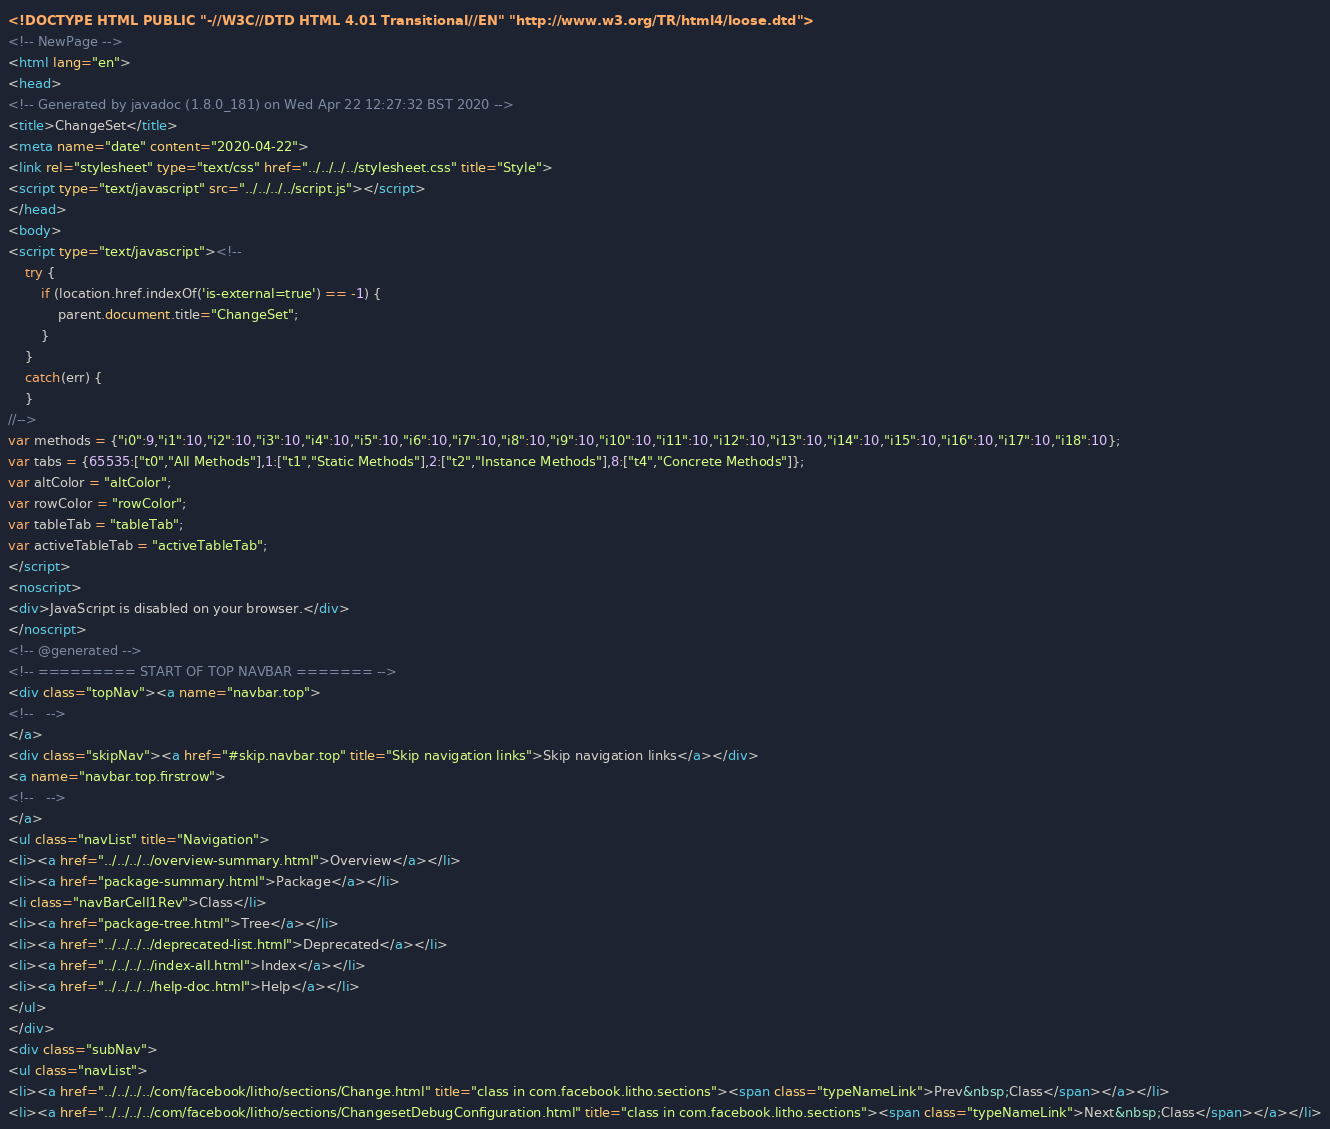Convert code to text. <code><loc_0><loc_0><loc_500><loc_500><_HTML_><!DOCTYPE HTML PUBLIC "-//W3C//DTD HTML 4.01 Transitional//EN" "http://www.w3.org/TR/html4/loose.dtd">
<!-- NewPage -->
<html lang="en">
<head>
<!-- Generated by javadoc (1.8.0_181) on Wed Apr 22 12:27:32 BST 2020 -->
<title>ChangeSet</title>
<meta name="date" content="2020-04-22">
<link rel="stylesheet" type="text/css" href="../../../../stylesheet.css" title="Style">
<script type="text/javascript" src="../../../../script.js"></script>
</head>
<body>
<script type="text/javascript"><!--
    try {
        if (location.href.indexOf('is-external=true') == -1) {
            parent.document.title="ChangeSet";
        }
    }
    catch(err) {
    }
//-->
var methods = {"i0":9,"i1":10,"i2":10,"i3":10,"i4":10,"i5":10,"i6":10,"i7":10,"i8":10,"i9":10,"i10":10,"i11":10,"i12":10,"i13":10,"i14":10,"i15":10,"i16":10,"i17":10,"i18":10};
var tabs = {65535:["t0","All Methods"],1:["t1","Static Methods"],2:["t2","Instance Methods"],8:["t4","Concrete Methods"]};
var altColor = "altColor";
var rowColor = "rowColor";
var tableTab = "tableTab";
var activeTableTab = "activeTableTab";
</script>
<noscript>
<div>JavaScript is disabled on your browser.</div>
</noscript>
<!-- @generated -->
<!-- ========= START OF TOP NAVBAR ======= -->
<div class="topNav"><a name="navbar.top">
<!--   -->
</a>
<div class="skipNav"><a href="#skip.navbar.top" title="Skip navigation links">Skip navigation links</a></div>
<a name="navbar.top.firstrow">
<!--   -->
</a>
<ul class="navList" title="Navigation">
<li><a href="../../../../overview-summary.html">Overview</a></li>
<li><a href="package-summary.html">Package</a></li>
<li class="navBarCell1Rev">Class</li>
<li><a href="package-tree.html">Tree</a></li>
<li><a href="../../../../deprecated-list.html">Deprecated</a></li>
<li><a href="../../../../index-all.html">Index</a></li>
<li><a href="../../../../help-doc.html">Help</a></li>
</ul>
</div>
<div class="subNav">
<ul class="navList">
<li><a href="../../../../com/facebook/litho/sections/Change.html" title="class in com.facebook.litho.sections"><span class="typeNameLink">Prev&nbsp;Class</span></a></li>
<li><a href="../../../../com/facebook/litho/sections/ChangesetDebugConfiguration.html" title="class in com.facebook.litho.sections"><span class="typeNameLink">Next&nbsp;Class</span></a></li></code> 